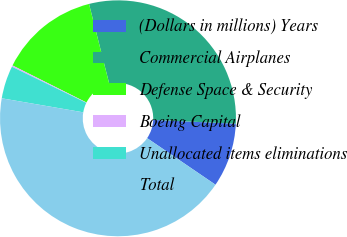<chart> <loc_0><loc_0><loc_500><loc_500><pie_chart><fcel>(Dollars in millions) Years<fcel>Commercial Airplanes<fcel>Defense Space & Security<fcel>Boeing Capital<fcel>Unallocated items eliminations<fcel>Total<nl><fcel>8.79%<fcel>29.68%<fcel>13.66%<fcel>0.19%<fcel>4.49%<fcel>43.2%<nl></chart> 